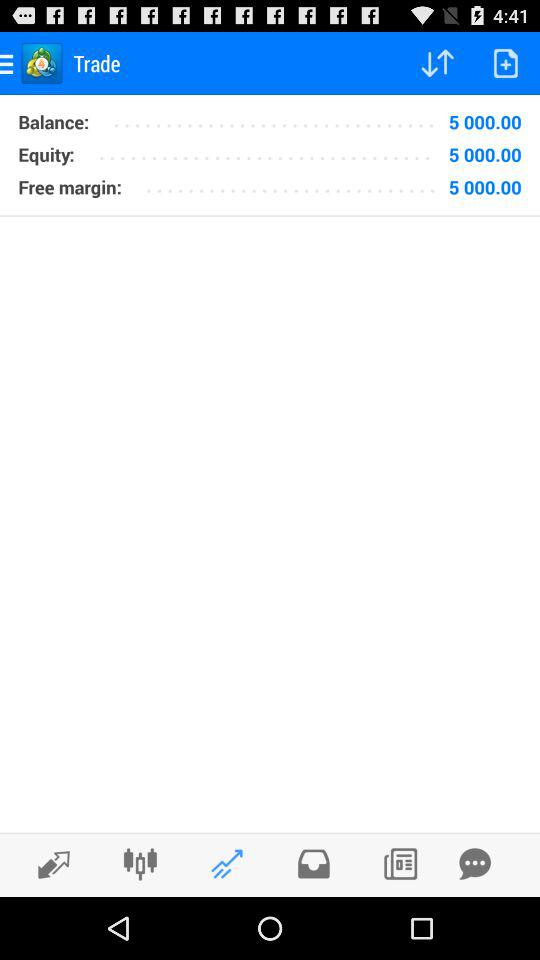How much amount in "Free margin"? The amount in "Free margin" is 5 000.00. 